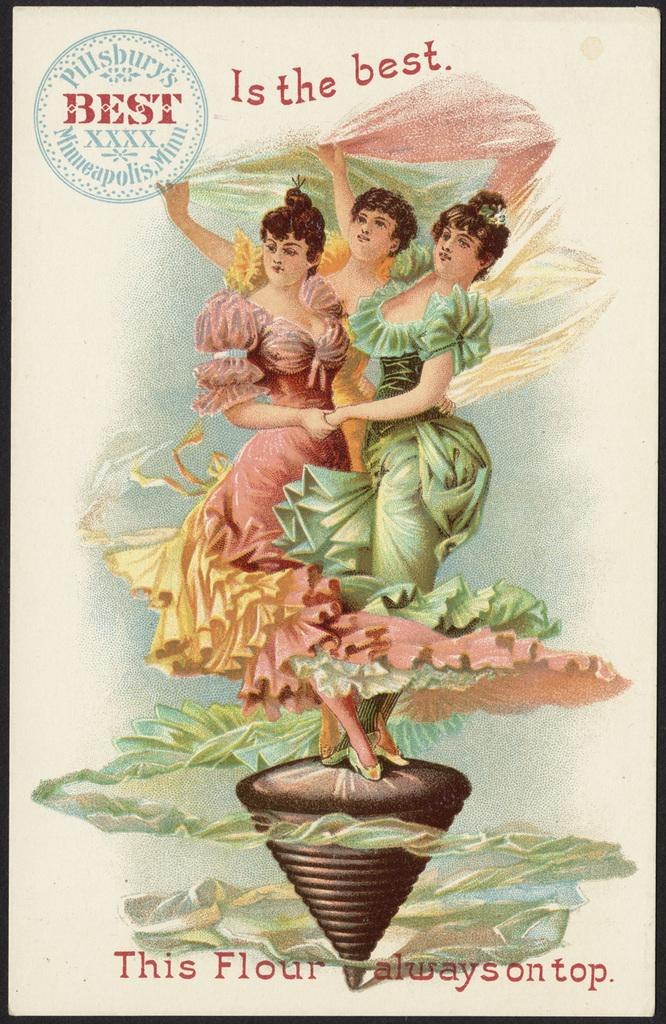<image>
Create a compact narrative representing the image presented. Three women in a poster that reads "Is the best." 